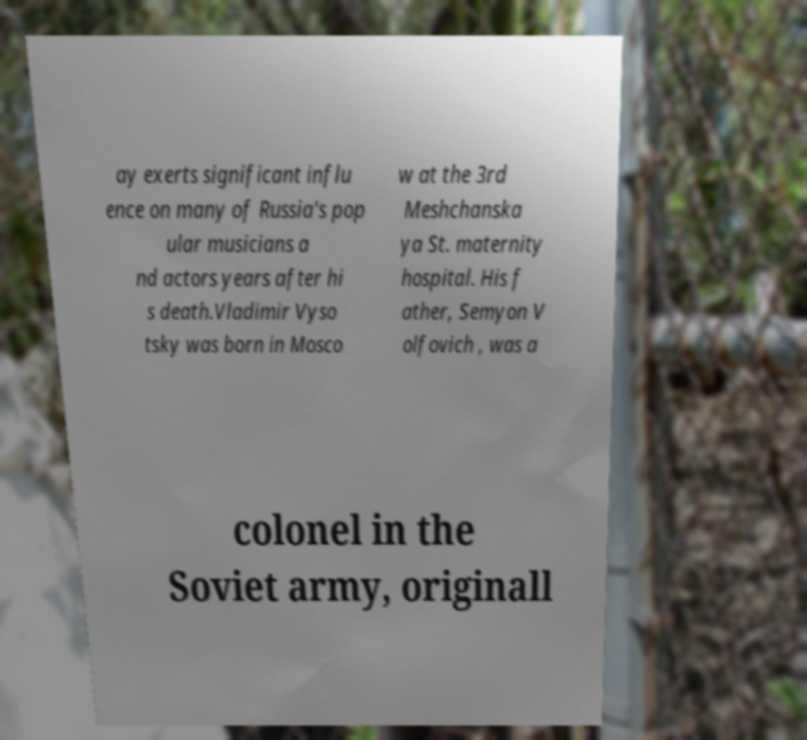What messages or text are displayed in this image? I need them in a readable, typed format. ay exerts significant influ ence on many of Russia's pop ular musicians a nd actors years after hi s death.Vladimir Vyso tsky was born in Mosco w at the 3rd Meshchanska ya St. maternity hospital. His f ather, Semyon V olfovich , was a colonel in the Soviet army, originall 